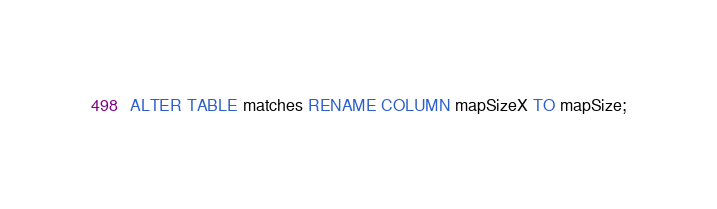<code> <loc_0><loc_0><loc_500><loc_500><_SQL_>ALTER TABLE matches RENAME COLUMN mapSizeX TO mapSize;</code> 